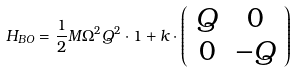Convert formula to latex. <formula><loc_0><loc_0><loc_500><loc_500>H _ { B O } = \frac { 1 } { 2 } M \Omega ^ { 2 } { Q } ^ { 2 } \cdot { 1 } + k \cdot \left ( \begin{array} { c c } Q & 0 \\ 0 & - Q \end{array} \right )</formula> 